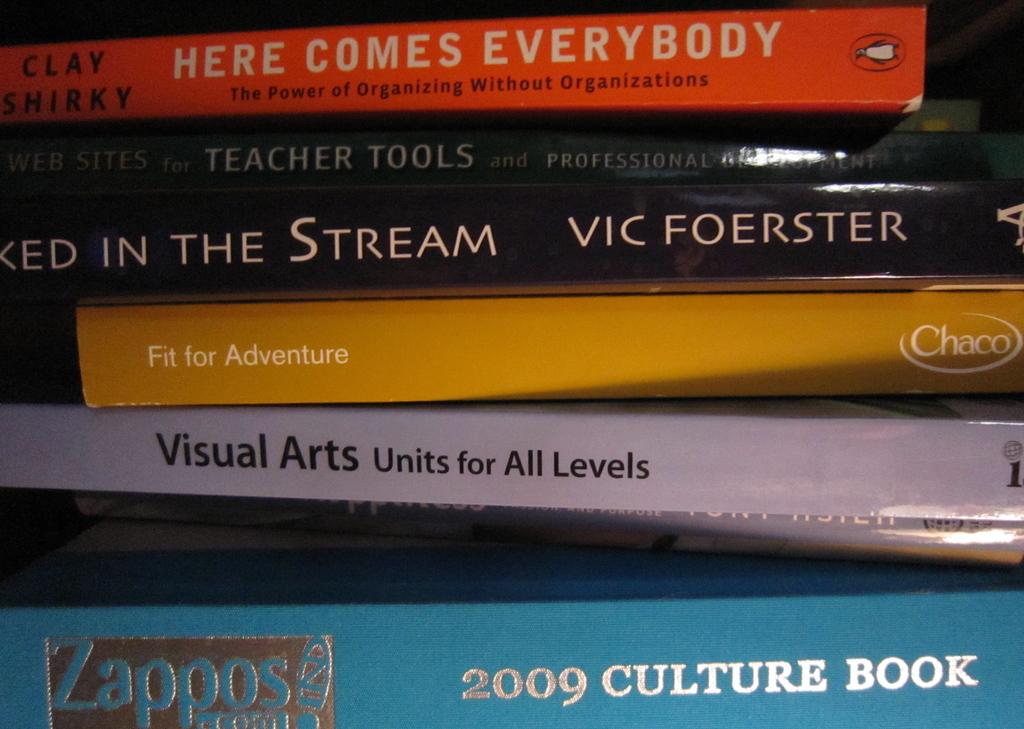What is the name of the blue book on the very bottom?
Your response must be concise. 2009 culture book. 